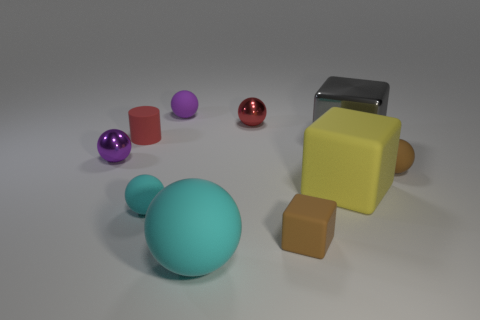Are there the same number of large gray objects that are to the right of the yellow matte cube and purple matte things on the right side of the gray block?
Your answer should be compact. No. There is a gray thing; how many yellow things are left of it?
Offer a terse response. 1. How many things are yellow objects or tiny brown objects?
Offer a very short reply. 3. What number of shiny things are the same size as the brown rubber cube?
Your answer should be compact. 2. The big thing that is in front of the big cube in front of the small brown sphere is what shape?
Your answer should be very brief. Sphere. Is the number of green cubes less than the number of small red cylinders?
Your response must be concise. Yes. What color is the big matte thing that is on the right side of the big cyan rubber thing?
Your answer should be very brief. Yellow. What is the material of the tiny object that is both to the left of the tiny red shiny thing and in front of the purple shiny thing?
Give a very brief answer. Rubber. The purple thing that is made of the same material as the gray thing is what shape?
Your answer should be compact. Sphere. What number of large things are on the right side of the small metallic object that is to the right of the purple rubber thing?
Your answer should be compact. 2. 